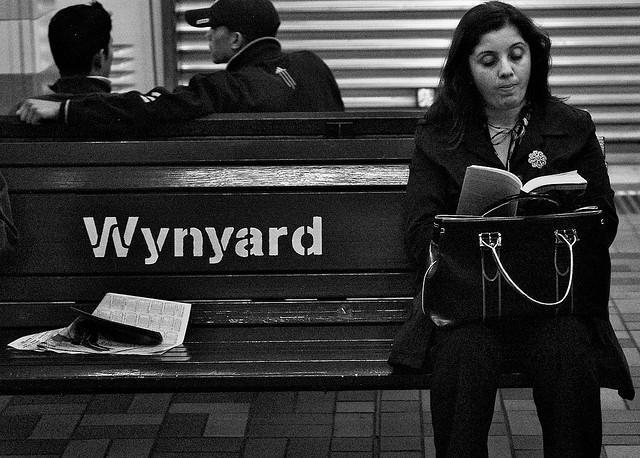How many benches are there?
Give a very brief answer. 2. How many books are visible?
Give a very brief answer. 1. How many people are visible?
Give a very brief answer. 3. How many train cars are there?
Give a very brief answer. 0. 